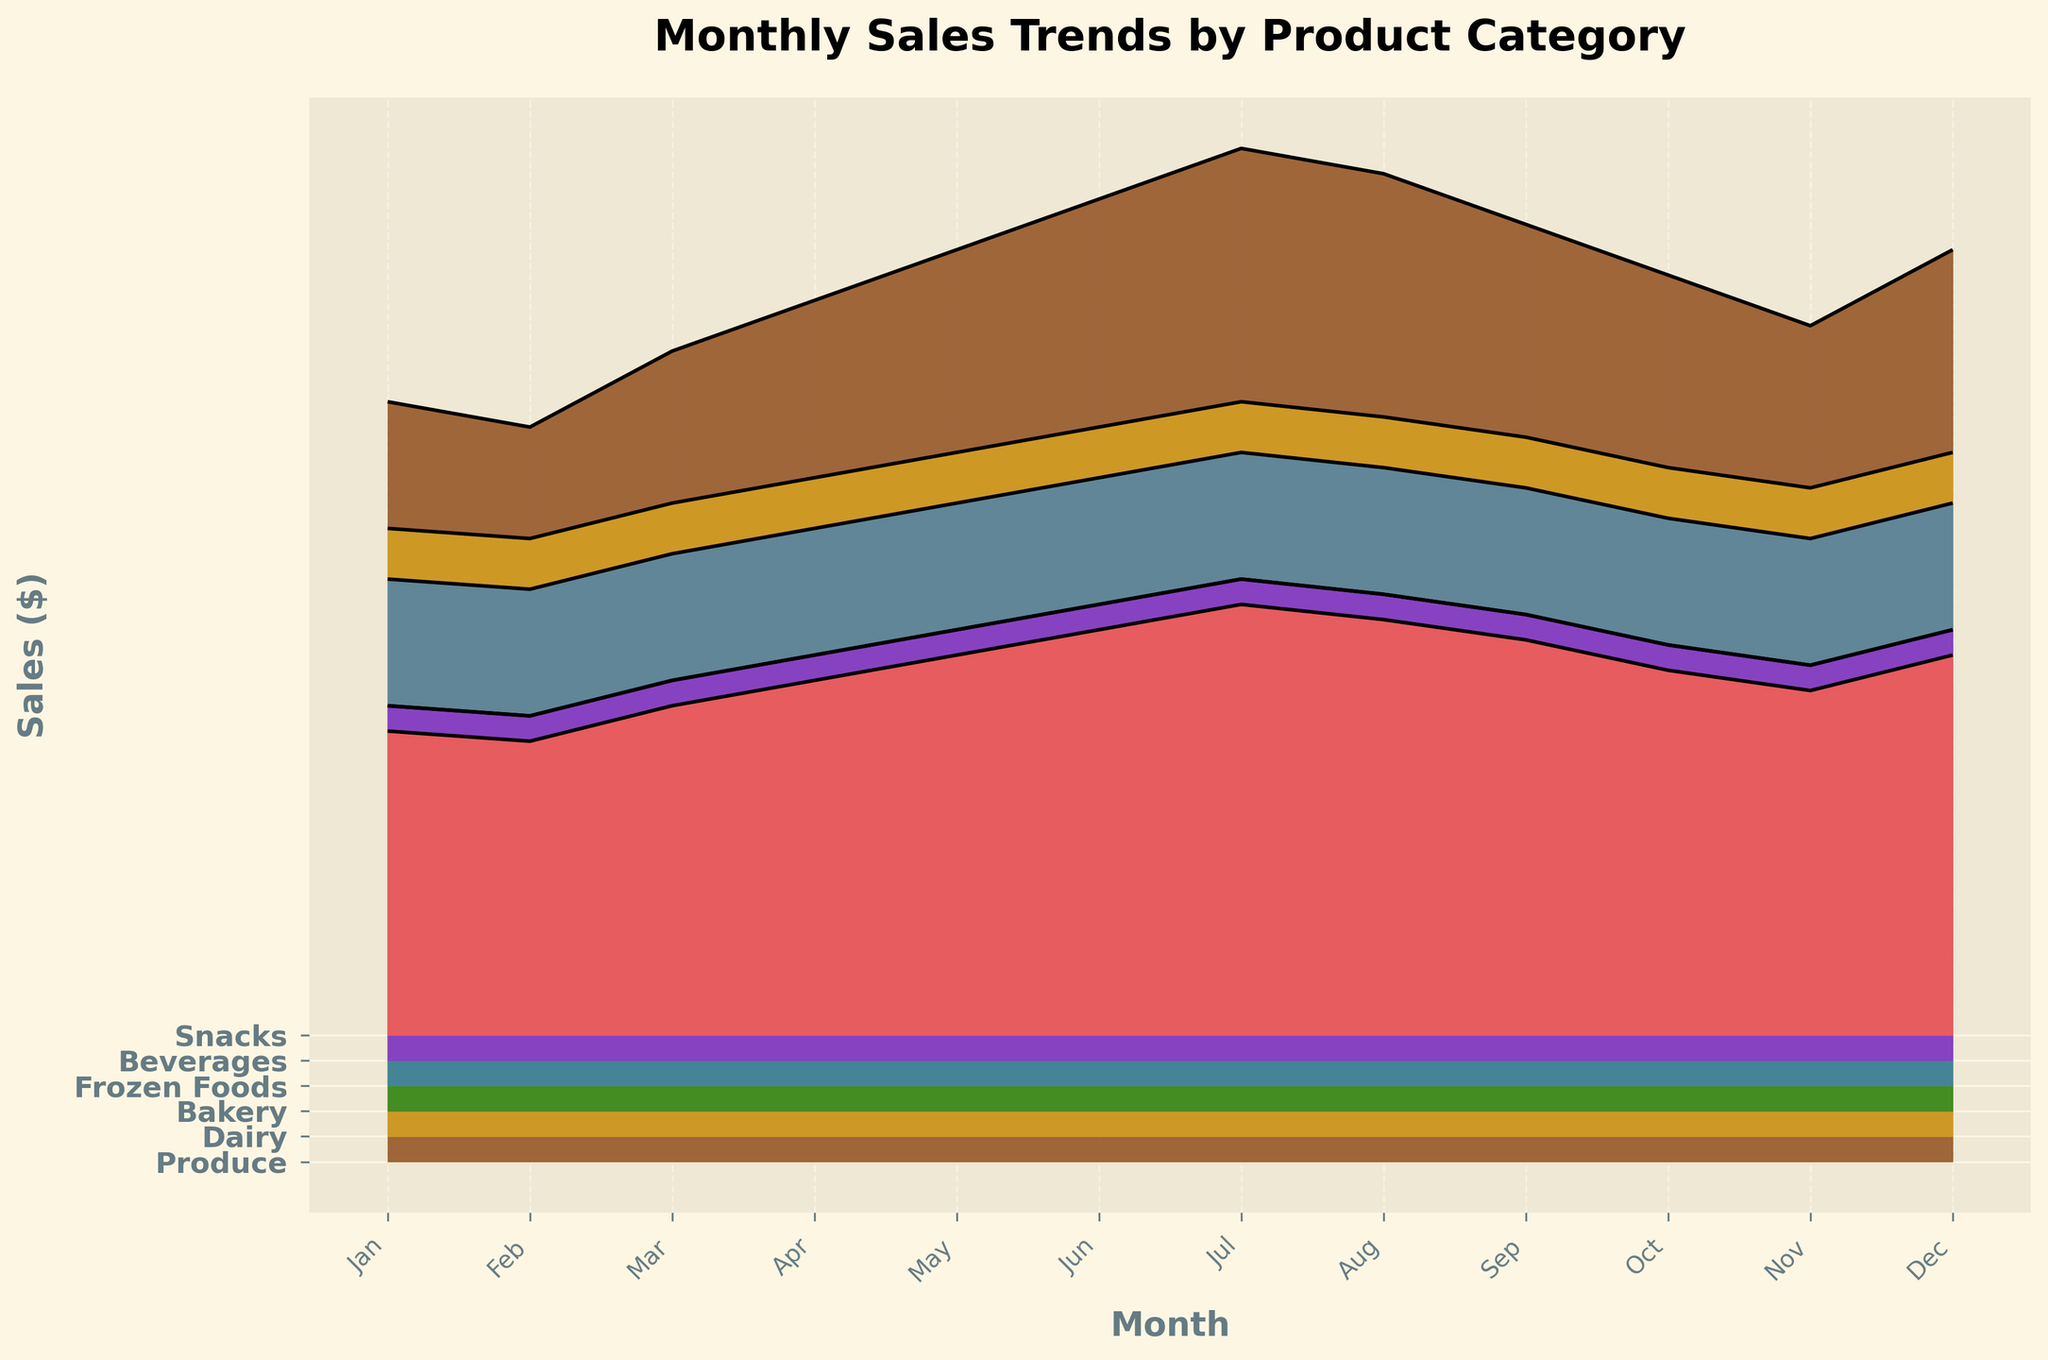What is the title of the plot? The title of the plot is located at the top of the figure and is clearly written in bold font.
Answer: Monthly Sales Trends by Product Category What do the colors represent in the plot? The colors represent different product categories in the grocery store, which are Produce, Dairy, Bakery, Frozen Foods, Beverages, and Snacks.
Answer: Different product categories Which month shows the highest sales for Bakery products? The highest point in the Bakery product ridge represents the highest sales. According to the plot, July has the highest sales for Bakery products.
Answer: July How do Dairy sales in March compare to Dairy sales in September? Evaluate the relative height of the Dairy line in March and September. Dairy sales in March are higher than in September.
Answer: Higher in March What is the overall trend for Produce sales across the year? The ridge for Produce rises steadily from January to July, dips slightly in August and September, and then decreases in October and November before rising again in December.
Answer: Increasing then decreasing, with a final rise Which product category experienced the most consistent sales throughout the year? Look at the smoothness and overall stability of each ridge. The ridge for Dairy appears the most level and consistent throughout the year.
Answer: Dairy Compare the sales for Beverages between April and October. Assess the height of the Beverages ridge in April and October. Sales for Beverages are higher in April than in October.
Answer: Higher in April What was the approximate range of sales values for Frozen Foods during the year? Estimating the lowest and highest points of the Frozen Foods ridge. The sales range from roughly 9800 (in February) to 12500 (in July).
Answer: 9800 to 12500 Which product category had the highest sales spike, and in which month did it occur? Identify the tallest single peak across all ridges. The highest spike is in Produce during July.
Answer: Produce in July By how much did Snack sales increase from February to December? Calculate the difference in ridge heights between February and December for Snacks. February sales are at 5800, and December sales are at 7500. The increase is 7500 - 5800.
Answer: 1700 